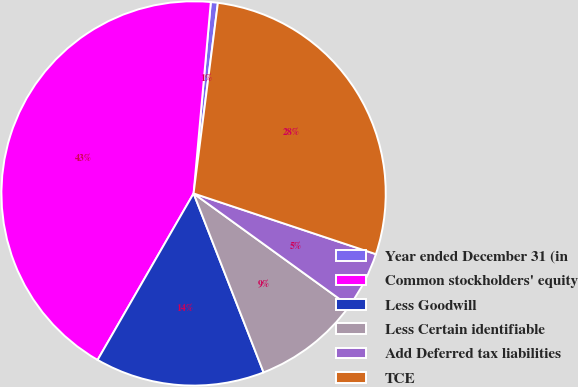Convert chart. <chart><loc_0><loc_0><loc_500><loc_500><pie_chart><fcel>Year ended December 31 (in<fcel>Common stockholders' equity<fcel>Less Goodwill<fcel>Less Certain identifiable<fcel>Add Deferred tax liabilities<fcel>TCE<nl><fcel>0.59%<fcel>43.11%<fcel>14.26%<fcel>9.1%<fcel>4.85%<fcel>28.1%<nl></chart> 